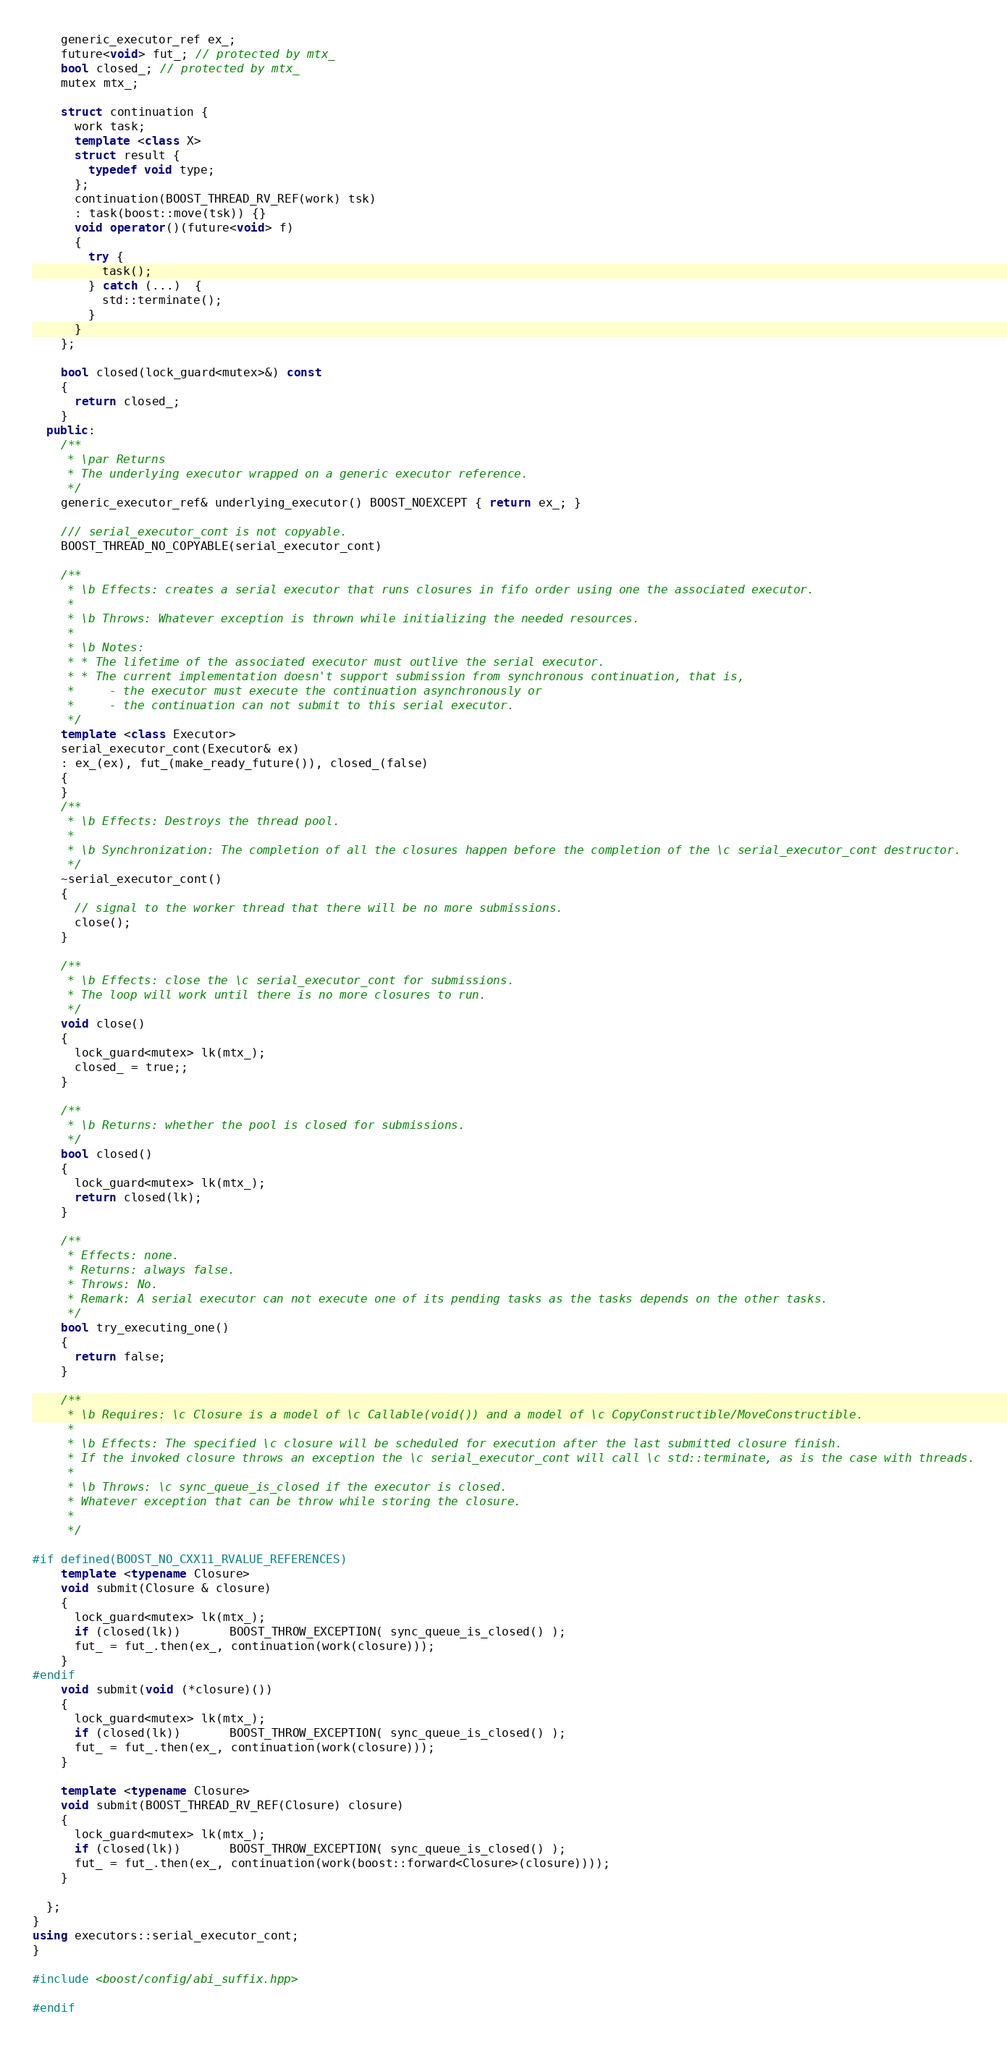Convert code to text. <code><loc_0><loc_0><loc_500><loc_500><_C++_>    generic_executor_ref ex_;
    future<void> fut_; // protected by mtx_
    bool closed_; // protected by mtx_
    mutex mtx_;

    struct continuation {
      work task;
      template <class X>
      struct result {
        typedef void type;
      };
      continuation(BOOST_THREAD_RV_REF(work) tsk)
      : task(boost::move(tsk)) {}
      void operator()(future<void> f)
      {
        try {
          task();
        } catch (...)  {
          std::terminate();
        }
      }
    };

    bool closed(lock_guard<mutex>&) const
    {
      return closed_;
    }
  public:
    /**
     * \par Returns
     * The underlying executor wrapped on a generic executor reference.
     */
    generic_executor_ref& underlying_executor() BOOST_NOEXCEPT { return ex_; }

    /// serial_executor_cont is not copyable.
    BOOST_THREAD_NO_COPYABLE(serial_executor_cont)

    /**
     * \b Effects: creates a serial executor that runs closures in fifo order using one the associated executor.
     *
     * \b Throws: Whatever exception is thrown while initializing the needed resources.
     *
     * \b Notes:
     * * The lifetime of the associated executor must outlive the serial executor.
     * * The current implementation doesn't support submission from synchronous continuation, that is,
     *     - the executor must execute the continuation asynchronously or
     *     - the continuation can not submit to this serial executor.
     */
    template <class Executor>
    serial_executor_cont(Executor& ex)
    : ex_(ex), fut_(make_ready_future()), closed_(false)
    {
    }
    /**
     * \b Effects: Destroys the thread pool.
     *
     * \b Synchronization: The completion of all the closures happen before the completion of the \c serial_executor_cont destructor.
     */
    ~serial_executor_cont()
    {
      // signal to the worker thread that there will be no more submissions.
      close();
    }

    /**
     * \b Effects: close the \c serial_executor_cont for submissions.
     * The loop will work until there is no more closures to run.
     */
    void close()
    {
      lock_guard<mutex> lk(mtx_);
      closed_ = true;;
    }

    /**
     * \b Returns: whether the pool is closed for submissions.
     */
    bool closed()
    {
      lock_guard<mutex> lk(mtx_);
      return closed(lk);
    }

    /**
     * Effects: none.
     * Returns: always false.
     * Throws: No.
     * Remark: A serial executor can not execute one of its pending tasks as the tasks depends on the other tasks.
     */
    bool try_executing_one()
    {
      return false;
    }

    /**
     * \b Requires: \c Closure is a model of \c Callable(void()) and a model of \c CopyConstructible/MoveConstructible.
     *
     * \b Effects: The specified \c closure will be scheduled for execution after the last submitted closure finish.
     * If the invoked closure throws an exception the \c serial_executor_cont will call \c std::terminate, as is the case with threads.
     *
     * \b Throws: \c sync_queue_is_closed if the executor is closed.
     * Whatever exception that can be throw while storing the closure.
     *
     */

#if defined(BOOST_NO_CXX11_RVALUE_REFERENCES)
    template <typename Closure>
    void submit(Closure & closure)
    {
      lock_guard<mutex> lk(mtx_);
      if (closed(lk))       BOOST_THROW_EXCEPTION( sync_queue_is_closed() );
      fut_ = fut_.then(ex_, continuation(work(closure)));
    }
#endif
    void submit(void (*closure)())
    {
      lock_guard<mutex> lk(mtx_);
      if (closed(lk))       BOOST_THROW_EXCEPTION( sync_queue_is_closed() );
      fut_ = fut_.then(ex_, continuation(work(closure)));
    }

    template <typename Closure>
    void submit(BOOST_THREAD_RV_REF(Closure) closure)
    {
      lock_guard<mutex> lk(mtx_);
      if (closed(lk))       BOOST_THROW_EXCEPTION( sync_queue_is_closed() );
      fut_ = fut_.then(ex_, continuation(work(boost::forward<Closure>(closure))));
    }

  };
}
using executors::serial_executor_cont;
}

#include <boost/config/abi_suffix.hpp>

#endif
</code> 